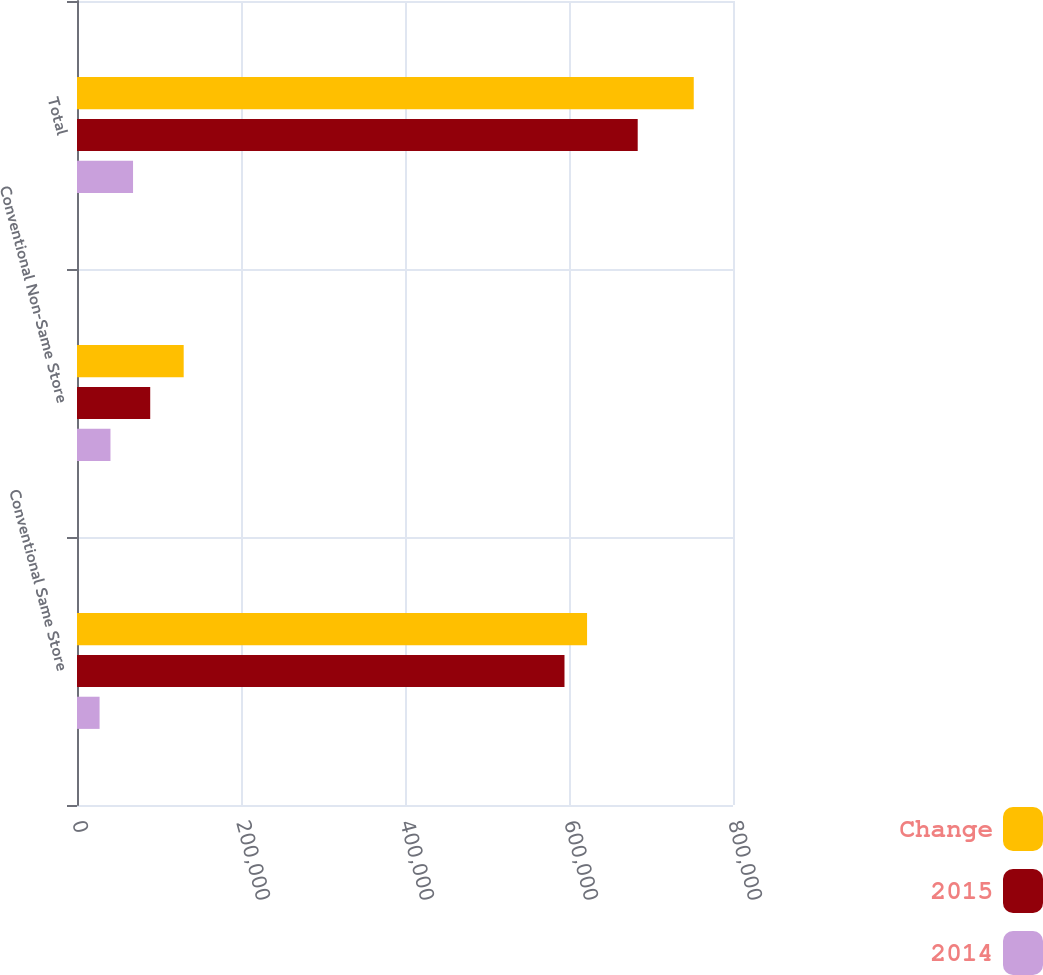<chart> <loc_0><loc_0><loc_500><loc_500><stacked_bar_chart><ecel><fcel>Conventional Same Store<fcel>Conventional Non-Same Store<fcel>Total<nl><fcel>Change<fcel>622031<fcel>130110<fcel>752141<nl><fcel>2015<fcel>594501<fcel>89290<fcel>683791<nl><fcel>2014<fcel>27530<fcel>40820<fcel>68350<nl></chart> 